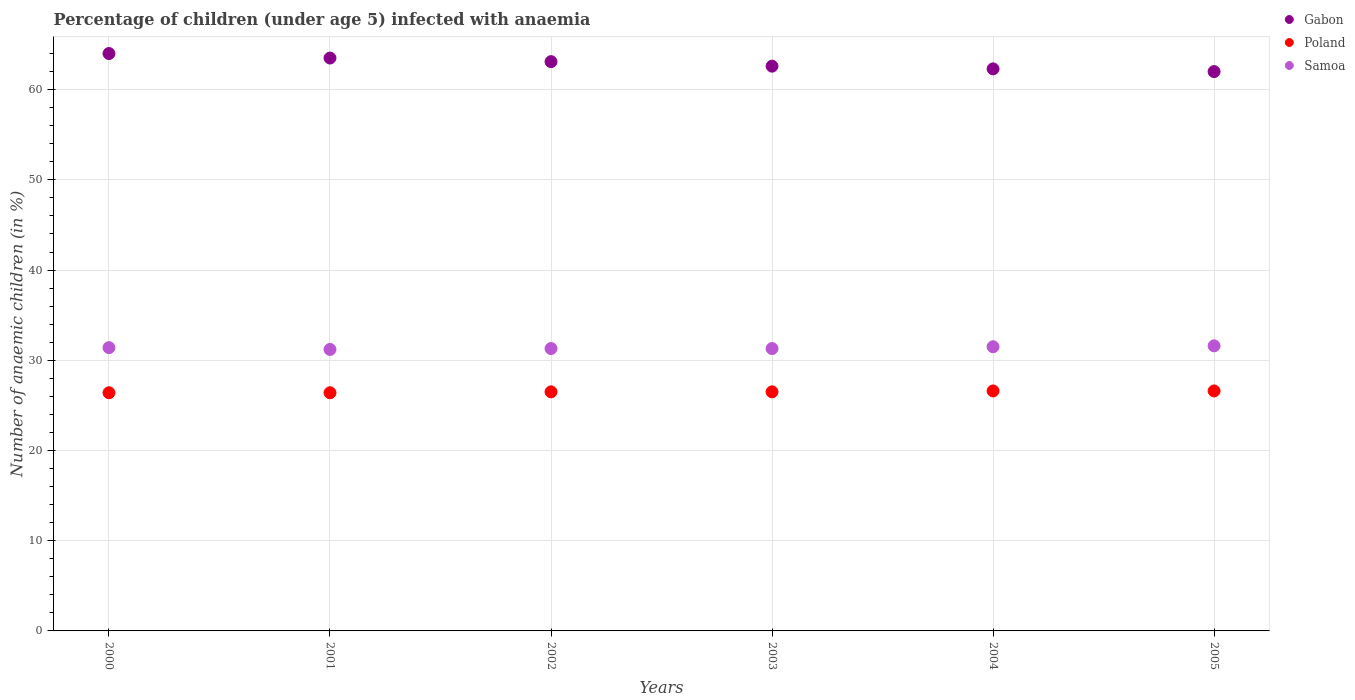How many different coloured dotlines are there?
Your response must be concise. 3. What is the percentage of children infected with anaemia in in Gabon in 2000?
Provide a short and direct response. 64. Across all years, what is the maximum percentage of children infected with anaemia in in Samoa?
Offer a very short reply. 31.6. Across all years, what is the minimum percentage of children infected with anaemia in in Poland?
Keep it short and to the point. 26.4. In which year was the percentage of children infected with anaemia in in Samoa maximum?
Offer a very short reply. 2005. What is the total percentage of children infected with anaemia in in Poland in the graph?
Ensure brevity in your answer.  159. What is the difference between the percentage of children infected with anaemia in in Gabon in 2003 and that in 2005?
Your answer should be very brief. 0.6. What is the difference between the percentage of children infected with anaemia in in Poland in 2001 and the percentage of children infected with anaemia in in Gabon in 2000?
Your answer should be very brief. -37.6. What is the average percentage of children infected with anaemia in in Samoa per year?
Your response must be concise. 31.38. In the year 2001, what is the difference between the percentage of children infected with anaemia in in Samoa and percentage of children infected with anaemia in in Gabon?
Offer a very short reply. -32.3. What is the ratio of the percentage of children infected with anaemia in in Samoa in 2001 to that in 2003?
Provide a short and direct response. 1. Is the difference between the percentage of children infected with anaemia in in Samoa in 2002 and 2005 greater than the difference between the percentage of children infected with anaemia in in Gabon in 2002 and 2005?
Ensure brevity in your answer.  No. In how many years, is the percentage of children infected with anaemia in in Samoa greater than the average percentage of children infected with anaemia in in Samoa taken over all years?
Your response must be concise. 3. Is the sum of the percentage of children infected with anaemia in in Gabon in 2001 and 2003 greater than the maximum percentage of children infected with anaemia in in Poland across all years?
Give a very brief answer. Yes. Is it the case that in every year, the sum of the percentage of children infected with anaemia in in Samoa and percentage of children infected with anaemia in in Gabon  is greater than the percentage of children infected with anaemia in in Poland?
Make the answer very short. Yes. Does the percentage of children infected with anaemia in in Samoa monotonically increase over the years?
Your response must be concise. No. Is the percentage of children infected with anaemia in in Gabon strictly less than the percentage of children infected with anaemia in in Samoa over the years?
Keep it short and to the point. No. How many dotlines are there?
Your response must be concise. 3. How many legend labels are there?
Your answer should be very brief. 3. How are the legend labels stacked?
Give a very brief answer. Vertical. What is the title of the graph?
Provide a short and direct response. Percentage of children (under age 5) infected with anaemia. What is the label or title of the Y-axis?
Your answer should be very brief. Number of anaemic children (in %). What is the Number of anaemic children (in %) in Gabon in 2000?
Your response must be concise. 64. What is the Number of anaemic children (in %) in Poland in 2000?
Offer a terse response. 26.4. What is the Number of anaemic children (in %) in Samoa in 2000?
Your answer should be compact. 31.4. What is the Number of anaemic children (in %) in Gabon in 2001?
Your answer should be compact. 63.5. What is the Number of anaemic children (in %) in Poland in 2001?
Give a very brief answer. 26.4. What is the Number of anaemic children (in %) in Samoa in 2001?
Make the answer very short. 31.2. What is the Number of anaemic children (in %) in Gabon in 2002?
Ensure brevity in your answer.  63.1. What is the Number of anaemic children (in %) of Poland in 2002?
Offer a very short reply. 26.5. What is the Number of anaemic children (in %) of Samoa in 2002?
Give a very brief answer. 31.3. What is the Number of anaemic children (in %) in Gabon in 2003?
Give a very brief answer. 62.6. What is the Number of anaemic children (in %) of Samoa in 2003?
Provide a succinct answer. 31.3. What is the Number of anaemic children (in %) of Gabon in 2004?
Make the answer very short. 62.3. What is the Number of anaemic children (in %) in Poland in 2004?
Keep it short and to the point. 26.6. What is the Number of anaemic children (in %) of Samoa in 2004?
Your answer should be very brief. 31.5. What is the Number of anaemic children (in %) in Gabon in 2005?
Your answer should be very brief. 62. What is the Number of anaemic children (in %) in Poland in 2005?
Your answer should be compact. 26.6. What is the Number of anaemic children (in %) in Samoa in 2005?
Keep it short and to the point. 31.6. Across all years, what is the maximum Number of anaemic children (in %) in Gabon?
Ensure brevity in your answer.  64. Across all years, what is the maximum Number of anaemic children (in %) in Poland?
Keep it short and to the point. 26.6. Across all years, what is the maximum Number of anaemic children (in %) of Samoa?
Provide a succinct answer. 31.6. Across all years, what is the minimum Number of anaemic children (in %) of Poland?
Keep it short and to the point. 26.4. Across all years, what is the minimum Number of anaemic children (in %) of Samoa?
Offer a very short reply. 31.2. What is the total Number of anaemic children (in %) in Gabon in the graph?
Provide a succinct answer. 377.5. What is the total Number of anaemic children (in %) in Poland in the graph?
Make the answer very short. 159. What is the total Number of anaemic children (in %) in Samoa in the graph?
Offer a terse response. 188.3. What is the difference between the Number of anaemic children (in %) in Poland in 2000 and that in 2001?
Your response must be concise. 0. What is the difference between the Number of anaemic children (in %) of Samoa in 2000 and that in 2001?
Offer a terse response. 0.2. What is the difference between the Number of anaemic children (in %) in Gabon in 2000 and that in 2002?
Provide a short and direct response. 0.9. What is the difference between the Number of anaemic children (in %) in Samoa in 2000 and that in 2002?
Provide a succinct answer. 0.1. What is the difference between the Number of anaemic children (in %) of Gabon in 2000 and that in 2003?
Keep it short and to the point. 1.4. What is the difference between the Number of anaemic children (in %) in Poland in 2000 and that in 2003?
Give a very brief answer. -0.1. What is the difference between the Number of anaemic children (in %) in Samoa in 2000 and that in 2003?
Provide a short and direct response. 0.1. What is the difference between the Number of anaemic children (in %) in Gabon in 2001 and that in 2002?
Provide a short and direct response. 0.4. What is the difference between the Number of anaemic children (in %) in Poland in 2001 and that in 2002?
Offer a terse response. -0.1. What is the difference between the Number of anaemic children (in %) in Samoa in 2001 and that in 2002?
Your answer should be compact. -0.1. What is the difference between the Number of anaemic children (in %) in Poland in 2001 and that in 2003?
Give a very brief answer. -0.1. What is the difference between the Number of anaemic children (in %) of Gabon in 2001 and that in 2004?
Make the answer very short. 1.2. What is the difference between the Number of anaemic children (in %) of Poland in 2001 and that in 2005?
Offer a terse response. -0.2. What is the difference between the Number of anaemic children (in %) of Samoa in 2002 and that in 2003?
Offer a terse response. 0. What is the difference between the Number of anaemic children (in %) in Gabon in 2002 and that in 2004?
Offer a terse response. 0.8. What is the difference between the Number of anaemic children (in %) in Poland in 2002 and that in 2004?
Make the answer very short. -0.1. What is the difference between the Number of anaemic children (in %) of Samoa in 2002 and that in 2004?
Provide a succinct answer. -0.2. What is the difference between the Number of anaemic children (in %) in Samoa in 2002 and that in 2005?
Your answer should be compact. -0.3. What is the difference between the Number of anaemic children (in %) in Gabon in 2003 and that in 2004?
Your answer should be very brief. 0.3. What is the difference between the Number of anaemic children (in %) of Poland in 2003 and that in 2004?
Your response must be concise. -0.1. What is the difference between the Number of anaemic children (in %) of Samoa in 2003 and that in 2004?
Make the answer very short. -0.2. What is the difference between the Number of anaemic children (in %) of Poland in 2003 and that in 2005?
Provide a short and direct response. -0.1. What is the difference between the Number of anaemic children (in %) of Samoa in 2003 and that in 2005?
Offer a very short reply. -0.3. What is the difference between the Number of anaemic children (in %) in Samoa in 2004 and that in 2005?
Your response must be concise. -0.1. What is the difference between the Number of anaemic children (in %) in Gabon in 2000 and the Number of anaemic children (in %) in Poland in 2001?
Offer a very short reply. 37.6. What is the difference between the Number of anaemic children (in %) in Gabon in 2000 and the Number of anaemic children (in %) in Samoa in 2001?
Give a very brief answer. 32.8. What is the difference between the Number of anaemic children (in %) in Gabon in 2000 and the Number of anaemic children (in %) in Poland in 2002?
Your answer should be very brief. 37.5. What is the difference between the Number of anaemic children (in %) of Gabon in 2000 and the Number of anaemic children (in %) of Samoa in 2002?
Your response must be concise. 32.7. What is the difference between the Number of anaemic children (in %) of Gabon in 2000 and the Number of anaemic children (in %) of Poland in 2003?
Give a very brief answer. 37.5. What is the difference between the Number of anaemic children (in %) in Gabon in 2000 and the Number of anaemic children (in %) in Samoa in 2003?
Provide a short and direct response. 32.7. What is the difference between the Number of anaemic children (in %) of Gabon in 2000 and the Number of anaemic children (in %) of Poland in 2004?
Ensure brevity in your answer.  37.4. What is the difference between the Number of anaemic children (in %) of Gabon in 2000 and the Number of anaemic children (in %) of Samoa in 2004?
Give a very brief answer. 32.5. What is the difference between the Number of anaemic children (in %) in Gabon in 2000 and the Number of anaemic children (in %) in Poland in 2005?
Your answer should be compact. 37.4. What is the difference between the Number of anaemic children (in %) of Gabon in 2000 and the Number of anaemic children (in %) of Samoa in 2005?
Provide a short and direct response. 32.4. What is the difference between the Number of anaemic children (in %) of Gabon in 2001 and the Number of anaemic children (in %) of Poland in 2002?
Offer a terse response. 37. What is the difference between the Number of anaemic children (in %) in Gabon in 2001 and the Number of anaemic children (in %) in Samoa in 2002?
Provide a short and direct response. 32.2. What is the difference between the Number of anaemic children (in %) in Gabon in 2001 and the Number of anaemic children (in %) in Poland in 2003?
Your answer should be very brief. 37. What is the difference between the Number of anaemic children (in %) of Gabon in 2001 and the Number of anaemic children (in %) of Samoa in 2003?
Your response must be concise. 32.2. What is the difference between the Number of anaemic children (in %) in Poland in 2001 and the Number of anaemic children (in %) in Samoa in 2003?
Your answer should be compact. -4.9. What is the difference between the Number of anaemic children (in %) of Gabon in 2001 and the Number of anaemic children (in %) of Poland in 2004?
Make the answer very short. 36.9. What is the difference between the Number of anaemic children (in %) of Gabon in 2001 and the Number of anaemic children (in %) of Samoa in 2004?
Your answer should be very brief. 32. What is the difference between the Number of anaemic children (in %) in Poland in 2001 and the Number of anaemic children (in %) in Samoa in 2004?
Provide a succinct answer. -5.1. What is the difference between the Number of anaemic children (in %) in Gabon in 2001 and the Number of anaemic children (in %) in Poland in 2005?
Ensure brevity in your answer.  36.9. What is the difference between the Number of anaemic children (in %) in Gabon in 2001 and the Number of anaemic children (in %) in Samoa in 2005?
Ensure brevity in your answer.  31.9. What is the difference between the Number of anaemic children (in %) of Gabon in 2002 and the Number of anaemic children (in %) of Poland in 2003?
Offer a very short reply. 36.6. What is the difference between the Number of anaemic children (in %) of Gabon in 2002 and the Number of anaemic children (in %) of Samoa in 2003?
Ensure brevity in your answer.  31.8. What is the difference between the Number of anaemic children (in %) of Poland in 2002 and the Number of anaemic children (in %) of Samoa in 2003?
Provide a short and direct response. -4.8. What is the difference between the Number of anaemic children (in %) in Gabon in 2002 and the Number of anaemic children (in %) in Poland in 2004?
Your answer should be compact. 36.5. What is the difference between the Number of anaemic children (in %) in Gabon in 2002 and the Number of anaemic children (in %) in Samoa in 2004?
Provide a succinct answer. 31.6. What is the difference between the Number of anaemic children (in %) of Gabon in 2002 and the Number of anaemic children (in %) of Poland in 2005?
Keep it short and to the point. 36.5. What is the difference between the Number of anaemic children (in %) in Gabon in 2002 and the Number of anaemic children (in %) in Samoa in 2005?
Offer a terse response. 31.5. What is the difference between the Number of anaemic children (in %) of Poland in 2002 and the Number of anaemic children (in %) of Samoa in 2005?
Make the answer very short. -5.1. What is the difference between the Number of anaemic children (in %) in Gabon in 2003 and the Number of anaemic children (in %) in Samoa in 2004?
Give a very brief answer. 31.1. What is the difference between the Number of anaemic children (in %) in Poland in 2003 and the Number of anaemic children (in %) in Samoa in 2004?
Your answer should be compact. -5. What is the difference between the Number of anaemic children (in %) in Gabon in 2004 and the Number of anaemic children (in %) in Poland in 2005?
Provide a short and direct response. 35.7. What is the difference between the Number of anaemic children (in %) in Gabon in 2004 and the Number of anaemic children (in %) in Samoa in 2005?
Offer a very short reply. 30.7. What is the difference between the Number of anaemic children (in %) in Poland in 2004 and the Number of anaemic children (in %) in Samoa in 2005?
Ensure brevity in your answer.  -5. What is the average Number of anaemic children (in %) in Gabon per year?
Provide a short and direct response. 62.92. What is the average Number of anaemic children (in %) of Poland per year?
Provide a short and direct response. 26.5. What is the average Number of anaemic children (in %) of Samoa per year?
Make the answer very short. 31.38. In the year 2000, what is the difference between the Number of anaemic children (in %) in Gabon and Number of anaemic children (in %) in Poland?
Ensure brevity in your answer.  37.6. In the year 2000, what is the difference between the Number of anaemic children (in %) in Gabon and Number of anaemic children (in %) in Samoa?
Give a very brief answer. 32.6. In the year 2001, what is the difference between the Number of anaemic children (in %) in Gabon and Number of anaemic children (in %) in Poland?
Give a very brief answer. 37.1. In the year 2001, what is the difference between the Number of anaemic children (in %) of Gabon and Number of anaemic children (in %) of Samoa?
Offer a very short reply. 32.3. In the year 2001, what is the difference between the Number of anaemic children (in %) in Poland and Number of anaemic children (in %) in Samoa?
Your response must be concise. -4.8. In the year 2002, what is the difference between the Number of anaemic children (in %) of Gabon and Number of anaemic children (in %) of Poland?
Give a very brief answer. 36.6. In the year 2002, what is the difference between the Number of anaemic children (in %) in Gabon and Number of anaemic children (in %) in Samoa?
Offer a terse response. 31.8. In the year 2002, what is the difference between the Number of anaemic children (in %) in Poland and Number of anaemic children (in %) in Samoa?
Your response must be concise. -4.8. In the year 2003, what is the difference between the Number of anaemic children (in %) in Gabon and Number of anaemic children (in %) in Poland?
Your answer should be compact. 36.1. In the year 2003, what is the difference between the Number of anaemic children (in %) of Gabon and Number of anaemic children (in %) of Samoa?
Your answer should be compact. 31.3. In the year 2004, what is the difference between the Number of anaemic children (in %) in Gabon and Number of anaemic children (in %) in Poland?
Ensure brevity in your answer.  35.7. In the year 2004, what is the difference between the Number of anaemic children (in %) of Gabon and Number of anaemic children (in %) of Samoa?
Offer a very short reply. 30.8. In the year 2004, what is the difference between the Number of anaemic children (in %) of Poland and Number of anaemic children (in %) of Samoa?
Give a very brief answer. -4.9. In the year 2005, what is the difference between the Number of anaemic children (in %) in Gabon and Number of anaemic children (in %) in Poland?
Ensure brevity in your answer.  35.4. In the year 2005, what is the difference between the Number of anaemic children (in %) of Gabon and Number of anaemic children (in %) of Samoa?
Give a very brief answer. 30.4. What is the ratio of the Number of anaemic children (in %) in Gabon in 2000 to that in 2001?
Ensure brevity in your answer.  1.01. What is the ratio of the Number of anaemic children (in %) of Poland in 2000 to that in 2001?
Give a very brief answer. 1. What is the ratio of the Number of anaemic children (in %) of Samoa in 2000 to that in 2001?
Your answer should be compact. 1.01. What is the ratio of the Number of anaemic children (in %) of Gabon in 2000 to that in 2002?
Keep it short and to the point. 1.01. What is the ratio of the Number of anaemic children (in %) in Poland in 2000 to that in 2002?
Provide a succinct answer. 1. What is the ratio of the Number of anaemic children (in %) of Gabon in 2000 to that in 2003?
Provide a short and direct response. 1.02. What is the ratio of the Number of anaemic children (in %) in Poland in 2000 to that in 2003?
Ensure brevity in your answer.  1. What is the ratio of the Number of anaemic children (in %) in Gabon in 2000 to that in 2004?
Ensure brevity in your answer.  1.03. What is the ratio of the Number of anaemic children (in %) of Poland in 2000 to that in 2004?
Offer a terse response. 0.99. What is the ratio of the Number of anaemic children (in %) of Gabon in 2000 to that in 2005?
Provide a short and direct response. 1.03. What is the ratio of the Number of anaemic children (in %) in Poland in 2000 to that in 2005?
Offer a terse response. 0.99. What is the ratio of the Number of anaemic children (in %) in Samoa in 2001 to that in 2002?
Provide a succinct answer. 1. What is the ratio of the Number of anaemic children (in %) in Gabon in 2001 to that in 2003?
Ensure brevity in your answer.  1.01. What is the ratio of the Number of anaemic children (in %) in Poland in 2001 to that in 2003?
Provide a short and direct response. 1. What is the ratio of the Number of anaemic children (in %) in Gabon in 2001 to that in 2004?
Keep it short and to the point. 1.02. What is the ratio of the Number of anaemic children (in %) of Poland in 2001 to that in 2004?
Keep it short and to the point. 0.99. What is the ratio of the Number of anaemic children (in %) in Samoa in 2001 to that in 2004?
Offer a terse response. 0.99. What is the ratio of the Number of anaemic children (in %) in Gabon in 2001 to that in 2005?
Offer a very short reply. 1.02. What is the ratio of the Number of anaemic children (in %) in Samoa in 2001 to that in 2005?
Give a very brief answer. 0.99. What is the ratio of the Number of anaemic children (in %) of Gabon in 2002 to that in 2003?
Your answer should be very brief. 1.01. What is the ratio of the Number of anaemic children (in %) in Poland in 2002 to that in 2003?
Provide a short and direct response. 1. What is the ratio of the Number of anaemic children (in %) of Gabon in 2002 to that in 2004?
Ensure brevity in your answer.  1.01. What is the ratio of the Number of anaemic children (in %) of Samoa in 2002 to that in 2004?
Give a very brief answer. 0.99. What is the ratio of the Number of anaemic children (in %) of Gabon in 2002 to that in 2005?
Give a very brief answer. 1.02. What is the ratio of the Number of anaemic children (in %) of Samoa in 2002 to that in 2005?
Offer a very short reply. 0.99. What is the ratio of the Number of anaemic children (in %) of Gabon in 2003 to that in 2004?
Your answer should be very brief. 1. What is the ratio of the Number of anaemic children (in %) in Samoa in 2003 to that in 2004?
Offer a very short reply. 0.99. What is the ratio of the Number of anaemic children (in %) of Gabon in 2003 to that in 2005?
Offer a terse response. 1.01. What is the ratio of the Number of anaemic children (in %) in Poland in 2003 to that in 2005?
Offer a terse response. 1. What is the ratio of the Number of anaemic children (in %) in Samoa in 2003 to that in 2005?
Give a very brief answer. 0.99. What is the ratio of the Number of anaemic children (in %) of Gabon in 2004 to that in 2005?
Give a very brief answer. 1. What is the ratio of the Number of anaemic children (in %) in Poland in 2004 to that in 2005?
Offer a terse response. 1. What is the ratio of the Number of anaemic children (in %) of Samoa in 2004 to that in 2005?
Offer a very short reply. 1. What is the difference between the highest and the second highest Number of anaemic children (in %) of Gabon?
Offer a terse response. 0.5. What is the difference between the highest and the second highest Number of anaemic children (in %) in Poland?
Provide a short and direct response. 0. What is the difference between the highest and the lowest Number of anaemic children (in %) of Gabon?
Your answer should be compact. 2. 